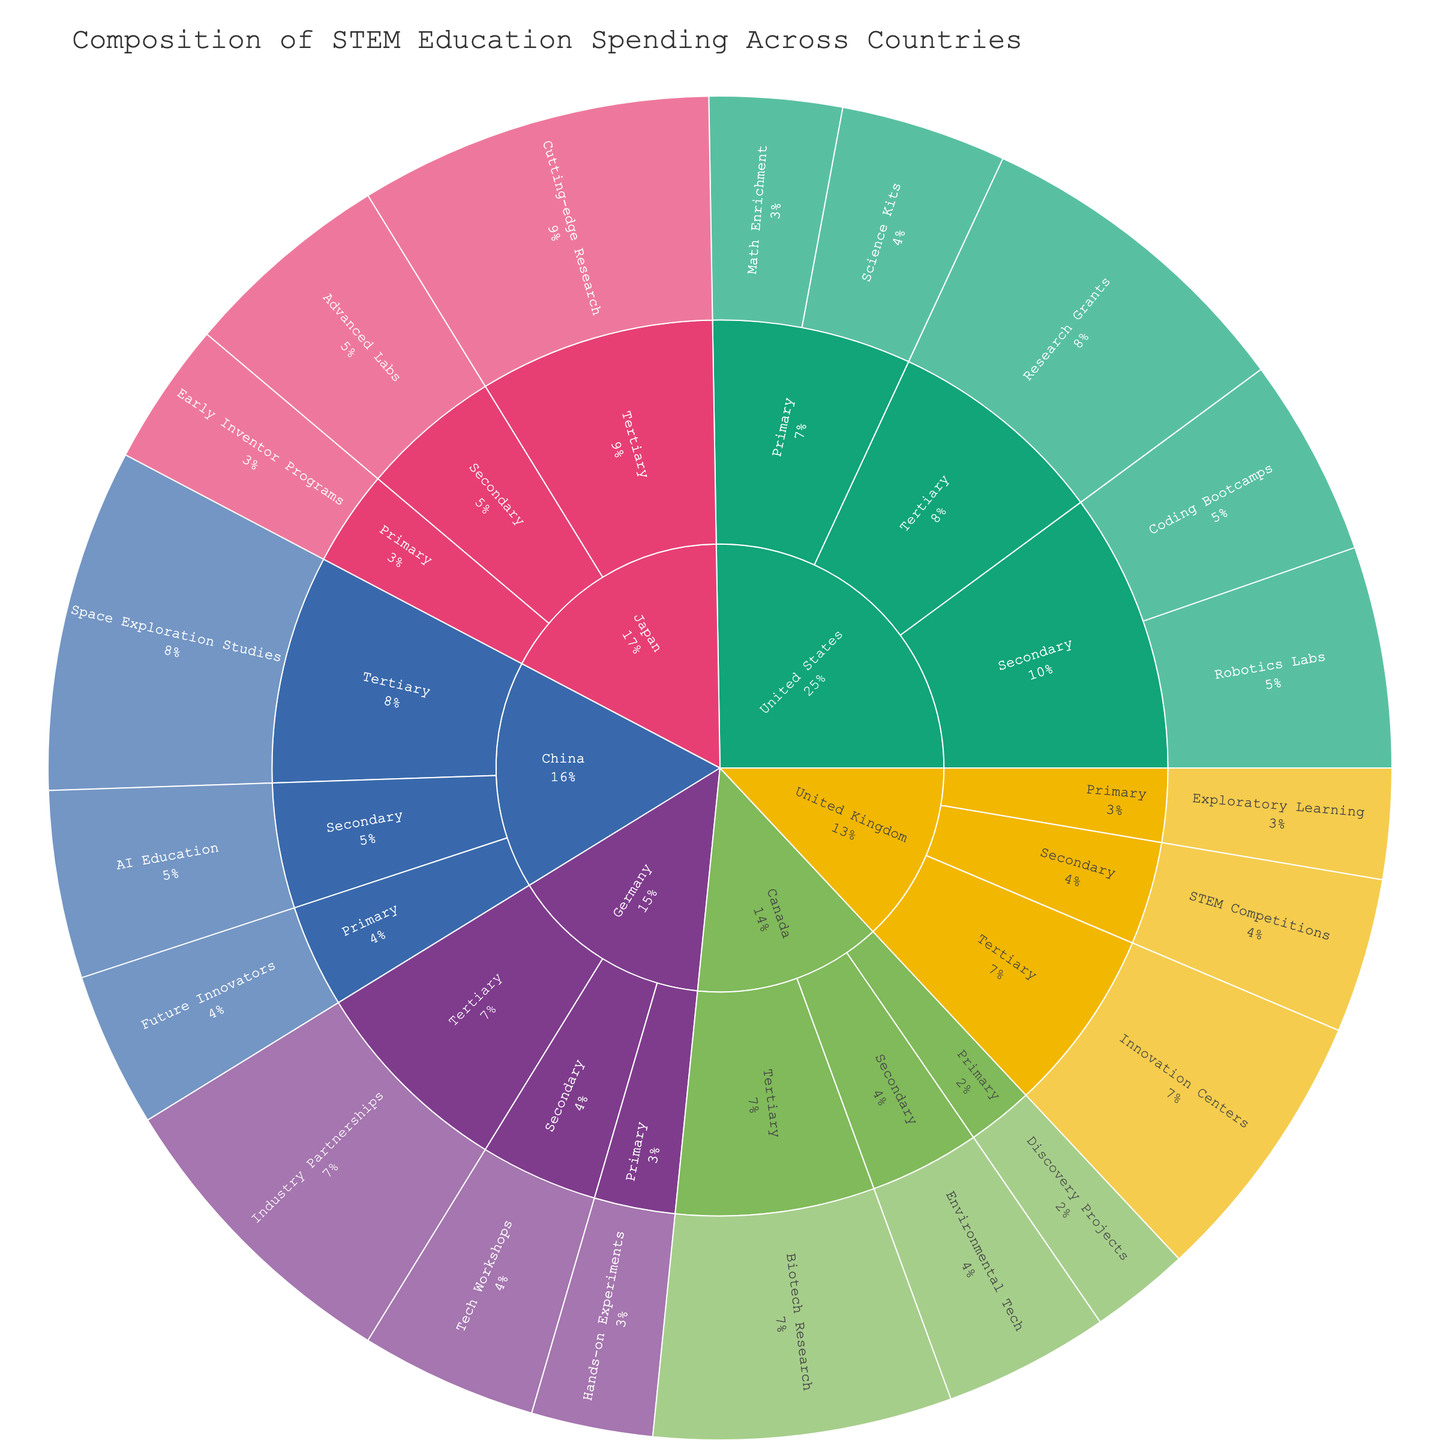What is the total spending on Primary level education in the United States? Sum of spending on 'Science Kits' and 'Math Enrichment' under Primary level in the United States. 150 + 120 = 270
Answer: 270 Which country spends the most on Tertiary level education? Compare the spending on Tertiary level education programs across all countries. Japan's spending is 320, which is the highest compared to others.
Answer: Japan What percentage of the total spending in Japan goes to the Secondary level? Sum total spending in Japan (Primary + Secondary + Tertiary) = 130 + 190 + 320 = 640; Secondary spending is 190. Calculate the percentage: (190 / 640) * 100 ≈ 29.7%
Answer: 29.7% Among all countries, which program receives the highest individual spending? Compare each program's spending from different countries. Japan's 'Cutting-edge Research' receives 320 which is the highest.
Answer: Cutting-edge Research How does spending on Robotics Labs in the United States compare to AI Education in China? Spending on Robotics Labs in the United States is 200 and AI Education in China is 170. 200 is greater than 170.
Answer: Robotics Labs spending is higher Which educational level has the smallest portion of spending in Canada? Compare the spending across Primary, Secondary, and Tertiary levels in Canada. Primary: 90, Secondary: 150, Tertiary: 270. 90 is the smallest.
Answer: Primary What is the total STEM education spending combined across all countries? Sum all spending across all records. 150+120+200+180+300+100+140+250+110+160+280+130+190+320+140+170+310+90+150+270 = 3830
Answer: 3830 Which country spends more on Primary level education, Germany or Canada? Compare Primary level spending between Germany (110) and Canada (90). 110 is greater than 90.
Answer: Germany 